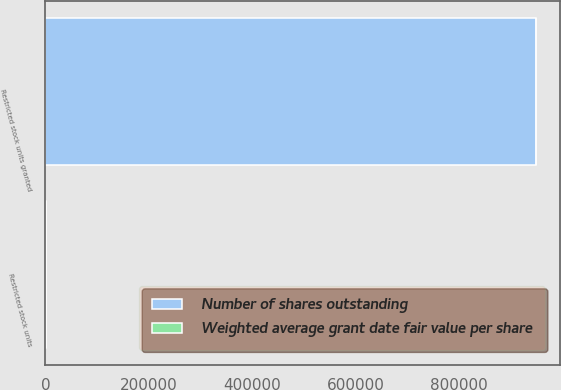Convert chart. <chart><loc_0><loc_0><loc_500><loc_500><stacked_bar_chart><ecel><fcel>Restricted stock units<fcel>Restricted stock units granted<nl><fcel>Number of shares outstanding<fcel>98.24<fcel>948442<nl><fcel>Weighted average grant date fair value per share<fcel>80.68<fcel>98.24<nl></chart> 